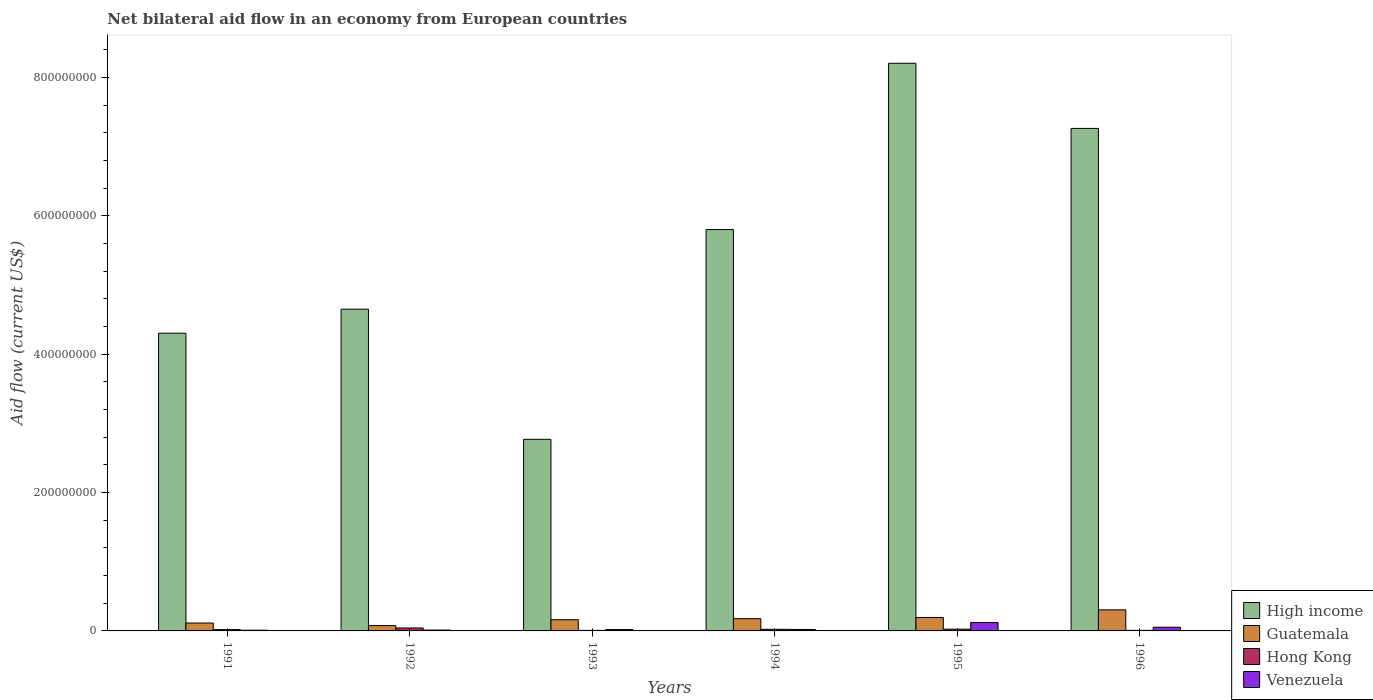How many different coloured bars are there?
Offer a terse response. 4. Are the number of bars per tick equal to the number of legend labels?
Offer a very short reply. Yes. How many bars are there on the 3rd tick from the left?
Provide a succinct answer. 4. How many bars are there on the 5th tick from the right?
Your answer should be compact. 4. What is the label of the 4th group of bars from the left?
Keep it short and to the point. 1994. What is the net bilateral aid flow in Guatemala in 1993?
Keep it short and to the point. 1.62e+07. Across all years, what is the maximum net bilateral aid flow in Hong Kong?
Offer a terse response. 4.26e+06. Across all years, what is the minimum net bilateral aid flow in High income?
Provide a succinct answer. 2.77e+08. What is the total net bilateral aid flow in Guatemala in the graph?
Provide a short and direct response. 1.03e+08. What is the difference between the net bilateral aid flow in Hong Kong in 1994 and that in 1996?
Your answer should be compact. 1.54e+06. What is the difference between the net bilateral aid flow in High income in 1993 and the net bilateral aid flow in Venezuela in 1996?
Make the answer very short. 2.72e+08. What is the average net bilateral aid flow in Hong Kong per year?
Your response must be concise. 2.11e+06. In the year 1992, what is the difference between the net bilateral aid flow in Guatemala and net bilateral aid flow in High income?
Ensure brevity in your answer.  -4.57e+08. In how many years, is the net bilateral aid flow in Venezuela greater than 720000000 US$?
Provide a succinct answer. 0. Is the difference between the net bilateral aid flow in Guatemala in 1991 and 1994 greater than the difference between the net bilateral aid flow in High income in 1991 and 1994?
Your response must be concise. Yes. What is the difference between the highest and the second highest net bilateral aid flow in High income?
Ensure brevity in your answer.  9.42e+07. What is the difference between the highest and the lowest net bilateral aid flow in Hong Kong?
Make the answer very short. 3.49e+06. Is it the case that in every year, the sum of the net bilateral aid flow in Guatemala and net bilateral aid flow in Venezuela is greater than the sum of net bilateral aid flow in High income and net bilateral aid flow in Hong Kong?
Provide a short and direct response. No. What does the 2nd bar from the left in 1994 represents?
Your response must be concise. Guatemala. What does the 3rd bar from the right in 1994 represents?
Ensure brevity in your answer.  Guatemala. Is it the case that in every year, the sum of the net bilateral aid flow in High income and net bilateral aid flow in Venezuela is greater than the net bilateral aid flow in Hong Kong?
Give a very brief answer. Yes. How many bars are there?
Your answer should be very brief. 24. How many years are there in the graph?
Provide a short and direct response. 6. Are the values on the major ticks of Y-axis written in scientific E-notation?
Your answer should be very brief. No. Does the graph contain grids?
Give a very brief answer. No. What is the title of the graph?
Offer a very short reply. Net bilateral aid flow in an economy from European countries. Does "Turkey" appear as one of the legend labels in the graph?
Provide a succinct answer. No. What is the label or title of the X-axis?
Your answer should be very brief. Years. What is the Aid flow (current US$) of High income in 1991?
Offer a very short reply. 4.30e+08. What is the Aid flow (current US$) in Guatemala in 1991?
Ensure brevity in your answer.  1.14e+07. What is the Aid flow (current US$) of Hong Kong in 1991?
Your answer should be compact. 1.92e+06. What is the Aid flow (current US$) of High income in 1992?
Keep it short and to the point. 4.65e+08. What is the Aid flow (current US$) of Guatemala in 1992?
Provide a short and direct response. 7.70e+06. What is the Aid flow (current US$) in Hong Kong in 1992?
Offer a terse response. 4.26e+06. What is the Aid flow (current US$) of Venezuela in 1992?
Provide a short and direct response. 1.30e+06. What is the Aid flow (current US$) of High income in 1993?
Your response must be concise. 2.77e+08. What is the Aid flow (current US$) of Guatemala in 1993?
Give a very brief answer. 1.62e+07. What is the Aid flow (current US$) of Hong Kong in 1993?
Give a very brief answer. 7.70e+05. What is the Aid flow (current US$) of Venezuela in 1993?
Your answer should be compact. 2.03e+06. What is the Aid flow (current US$) in High income in 1994?
Offer a terse response. 5.80e+08. What is the Aid flow (current US$) in Guatemala in 1994?
Provide a short and direct response. 1.77e+07. What is the Aid flow (current US$) of Hong Kong in 1994?
Keep it short and to the point. 2.34e+06. What is the Aid flow (current US$) of Venezuela in 1994?
Your answer should be compact. 2.14e+06. What is the Aid flow (current US$) of High income in 1995?
Give a very brief answer. 8.20e+08. What is the Aid flow (current US$) in Guatemala in 1995?
Your response must be concise. 1.94e+07. What is the Aid flow (current US$) of Hong Kong in 1995?
Keep it short and to the point. 2.57e+06. What is the Aid flow (current US$) in Venezuela in 1995?
Offer a terse response. 1.21e+07. What is the Aid flow (current US$) in High income in 1996?
Your answer should be very brief. 7.26e+08. What is the Aid flow (current US$) of Guatemala in 1996?
Offer a terse response. 3.04e+07. What is the Aid flow (current US$) in Hong Kong in 1996?
Your response must be concise. 8.00e+05. What is the Aid flow (current US$) of Venezuela in 1996?
Provide a short and direct response. 5.33e+06. Across all years, what is the maximum Aid flow (current US$) of High income?
Your answer should be very brief. 8.20e+08. Across all years, what is the maximum Aid flow (current US$) in Guatemala?
Provide a short and direct response. 3.04e+07. Across all years, what is the maximum Aid flow (current US$) in Hong Kong?
Keep it short and to the point. 4.26e+06. Across all years, what is the maximum Aid flow (current US$) in Venezuela?
Your answer should be compact. 1.21e+07. Across all years, what is the minimum Aid flow (current US$) in High income?
Your answer should be compact. 2.77e+08. Across all years, what is the minimum Aid flow (current US$) in Guatemala?
Your answer should be very brief. 7.70e+06. Across all years, what is the minimum Aid flow (current US$) of Hong Kong?
Keep it short and to the point. 7.70e+05. What is the total Aid flow (current US$) in High income in the graph?
Provide a succinct answer. 3.30e+09. What is the total Aid flow (current US$) in Guatemala in the graph?
Provide a short and direct response. 1.03e+08. What is the total Aid flow (current US$) of Hong Kong in the graph?
Make the answer very short. 1.27e+07. What is the total Aid flow (current US$) in Venezuela in the graph?
Ensure brevity in your answer.  2.39e+07. What is the difference between the Aid flow (current US$) in High income in 1991 and that in 1992?
Your response must be concise. -3.48e+07. What is the difference between the Aid flow (current US$) in Guatemala in 1991 and that in 1992?
Your answer should be very brief. 3.71e+06. What is the difference between the Aid flow (current US$) of Hong Kong in 1991 and that in 1992?
Make the answer very short. -2.34e+06. What is the difference between the Aid flow (current US$) of High income in 1991 and that in 1993?
Your answer should be very brief. 1.53e+08. What is the difference between the Aid flow (current US$) in Guatemala in 1991 and that in 1993?
Give a very brief answer. -4.78e+06. What is the difference between the Aid flow (current US$) of Hong Kong in 1991 and that in 1993?
Provide a short and direct response. 1.15e+06. What is the difference between the Aid flow (current US$) in Venezuela in 1991 and that in 1993?
Offer a very short reply. -1.03e+06. What is the difference between the Aid flow (current US$) in High income in 1991 and that in 1994?
Provide a succinct answer. -1.50e+08. What is the difference between the Aid flow (current US$) of Guatemala in 1991 and that in 1994?
Keep it short and to the point. -6.28e+06. What is the difference between the Aid flow (current US$) in Hong Kong in 1991 and that in 1994?
Give a very brief answer. -4.20e+05. What is the difference between the Aid flow (current US$) in Venezuela in 1991 and that in 1994?
Your answer should be very brief. -1.14e+06. What is the difference between the Aid flow (current US$) of High income in 1991 and that in 1995?
Provide a short and direct response. -3.90e+08. What is the difference between the Aid flow (current US$) in Guatemala in 1991 and that in 1995?
Keep it short and to the point. -8.02e+06. What is the difference between the Aid flow (current US$) of Hong Kong in 1991 and that in 1995?
Provide a succinct answer. -6.50e+05. What is the difference between the Aid flow (current US$) in Venezuela in 1991 and that in 1995?
Offer a very short reply. -1.11e+07. What is the difference between the Aid flow (current US$) of High income in 1991 and that in 1996?
Ensure brevity in your answer.  -2.96e+08. What is the difference between the Aid flow (current US$) in Guatemala in 1991 and that in 1996?
Provide a short and direct response. -1.90e+07. What is the difference between the Aid flow (current US$) in Hong Kong in 1991 and that in 1996?
Offer a very short reply. 1.12e+06. What is the difference between the Aid flow (current US$) of Venezuela in 1991 and that in 1996?
Keep it short and to the point. -4.33e+06. What is the difference between the Aid flow (current US$) in High income in 1992 and that in 1993?
Make the answer very short. 1.88e+08. What is the difference between the Aid flow (current US$) in Guatemala in 1992 and that in 1993?
Give a very brief answer. -8.49e+06. What is the difference between the Aid flow (current US$) of Hong Kong in 1992 and that in 1993?
Your answer should be very brief. 3.49e+06. What is the difference between the Aid flow (current US$) in Venezuela in 1992 and that in 1993?
Offer a terse response. -7.30e+05. What is the difference between the Aid flow (current US$) of High income in 1992 and that in 1994?
Provide a succinct answer. -1.15e+08. What is the difference between the Aid flow (current US$) in Guatemala in 1992 and that in 1994?
Offer a very short reply. -9.99e+06. What is the difference between the Aid flow (current US$) of Hong Kong in 1992 and that in 1994?
Offer a terse response. 1.92e+06. What is the difference between the Aid flow (current US$) of Venezuela in 1992 and that in 1994?
Provide a succinct answer. -8.40e+05. What is the difference between the Aid flow (current US$) of High income in 1992 and that in 1995?
Your answer should be compact. -3.55e+08. What is the difference between the Aid flow (current US$) in Guatemala in 1992 and that in 1995?
Your answer should be compact. -1.17e+07. What is the difference between the Aid flow (current US$) in Hong Kong in 1992 and that in 1995?
Your response must be concise. 1.69e+06. What is the difference between the Aid flow (current US$) in Venezuela in 1992 and that in 1995?
Your response must be concise. -1.08e+07. What is the difference between the Aid flow (current US$) in High income in 1992 and that in 1996?
Ensure brevity in your answer.  -2.61e+08. What is the difference between the Aid flow (current US$) in Guatemala in 1992 and that in 1996?
Give a very brief answer. -2.27e+07. What is the difference between the Aid flow (current US$) in Hong Kong in 1992 and that in 1996?
Offer a very short reply. 3.46e+06. What is the difference between the Aid flow (current US$) of Venezuela in 1992 and that in 1996?
Make the answer very short. -4.03e+06. What is the difference between the Aid flow (current US$) of High income in 1993 and that in 1994?
Give a very brief answer. -3.03e+08. What is the difference between the Aid flow (current US$) in Guatemala in 1993 and that in 1994?
Your answer should be compact. -1.50e+06. What is the difference between the Aid flow (current US$) of Hong Kong in 1993 and that in 1994?
Give a very brief answer. -1.57e+06. What is the difference between the Aid flow (current US$) in Venezuela in 1993 and that in 1994?
Provide a succinct answer. -1.10e+05. What is the difference between the Aid flow (current US$) in High income in 1993 and that in 1995?
Your answer should be very brief. -5.43e+08. What is the difference between the Aid flow (current US$) in Guatemala in 1993 and that in 1995?
Give a very brief answer. -3.24e+06. What is the difference between the Aid flow (current US$) in Hong Kong in 1993 and that in 1995?
Your response must be concise. -1.80e+06. What is the difference between the Aid flow (current US$) in Venezuela in 1993 and that in 1995?
Give a very brief answer. -1.01e+07. What is the difference between the Aid flow (current US$) of High income in 1993 and that in 1996?
Offer a terse response. -4.49e+08. What is the difference between the Aid flow (current US$) of Guatemala in 1993 and that in 1996?
Provide a succinct answer. -1.42e+07. What is the difference between the Aid flow (current US$) of Hong Kong in 1993 and that in 1996?
Your response must be concise. -3.00e+04. What is the difference between the Aid flow (current US$) in Venezuela in 1993 and that in 1996?
Keep it short and to the point. -3.30e+06. What is the difference between the Aid flow (current US$) of High income in 1994 and that in 1995?
Offer a terse response. -2.40e+08. What is the difference between the Aid flow (current US$) of Guatemala in 1994 and that in 1995?
Provide a succinct answer. -1.74e+06. What is the difference between the Aid flow (current US$) of Hong Kong in 1994 and that in 1995?
Keep it short and to the point. -2.30e+05. What is the difference between the Aid flow (current US$) of Venezuela in 1994 and that in 1995?
Give a very brief answer. -9.96e+06. What is the difference between the Aid flow (current US$) of High income in 1994 and that in 1996?
Your response must be concise. -1.46e+08. What is the difference between the Aid flow (current US$) of Guatemala in 1994 and that in 1996?
Your answer should be compact. -1.27e+07. What is the difference between the Aid flow (current US$) of Hong Kong in 1994 and that in 1996?
Provide a succinct answer. 1.54e+06. What is the difference between the Aid flow (current US$) of Venezuela in 1994 and that in 1996?
Your response must be concise. -3.19e+06. What is the difference between the Aid flow (current US$) in High income in 1995 and that in 1996?
Ensure brevity in your answer.  9.42e+07. What is the difference between the Aid flow (current US$) in Guatemala in 1995 and that in 1996?
Your answer should be compact. -1.10e+07. What is the difference between the Aid flow (current US$) of Hong Kong in 1995 and that in 1996?
Your response must be concise. 1.77e+06. What is the difference between the Aid flow (current US$) in Venezuela in 1995 and that in 1996?
Provide a succinct answer. 6.77e+06. What is the difference between the Aid flow (current US$) of High income in 1991 and the Aid flow (current US$) of Guatemala in 1992?
Provide a succinct answer. 4.23e+08. What is the difference between the Aid flow (current US$) in High income in 1991 and the Aid flow (current US$) in Hong Kong in 1992?
Give a very brief answer. 4.26e+08. What is the difference between the Aid flow (current US$) of High income in 1991 and the Aid flow (current US$) of Venezuela in 1992?
Your answer should be very brief. 4.29e+08. What is the difference between the Aid flow (current US$) in Guatemala in 1991 and the Aid flow (current US$) in Hong Kong in 1992?
Provide a short and direct response. 7.15e+06. What is the difference between the Aid flow (current US$) in Guatemala in 1991 and the Aid flow (current US$) in Venezuela in 1992?
Provide a succinct answer. 1.01e+07. What is the difference between the Aid flow (current US$) in Hong Kong in 1991 and the Aid flow (current US$) in Venezuela in 1992?
Provide a succinct answer. 6.20e+05. What is the difference between the Aid flow (current US$) in High income in 1991 and the Aid flow (current US$) in Guatemala in 1993?
Offer a terse response. 4.14e+08. What is the difference between the Aid flow (current US$) in High income in 1991 and the Aid flow (current US$) in Hong Kong in 1993?
Offer a terse response. 4.29e+08. What is the difference between the Aid flow (current US$) in High income in 1991 and the Aid flow (current US$) in Venezuela in 1993?
Provide a succinct answer. 4.28e+08. What is the difference between the Aid flow (current US$) in Guatemala in 1991 and the Aid flow (current US$) in Hong Kong in 1993?
Make the answer very short. 1.06e+07. What is the difference between the Aid flow (current US$) of Guatemala in 1991 and the Aid flow (current US$) of Venezuela in 1993?
Give a very brief answer. 9.38e+06. What is the difference between the Aid flow (current US$) of High income in 1991 and the Aid flow (current US$) of Guatemala in 1994?
Offer a terse response. 4.13e+08. What is the difference between the Aid flow (current US$) of High income in 1991 and the Aid flow (current US$) of Hong Kong in 1994?
Give a very brief answer. 4.28e+08. What is the difference between the Aid flow (current US$) in High income in 1991 and the Aid flow (current US$) in Venezuela in 1994?
Offer a terse response. 4.28e+08. What is the difference between the Aid flow (current US$) of Guatemala in 1991 and the Aid flow (current US$) of Hong Kong in 1994?
Provide a short and direct response. 9.07e+06. What is the difference between the Aid flow (current US$) of Guatemala in 1991 and the Aid flow (current US$) of Venezuela in 1994?
Your response must be concise. 9.27e+06. What is the difference between the Aid flow (current US$) of High income in 1991 and the Aid flow (current US$) of Guatemala in 1995?
Offer a very short reply. 4.11e+08. What is the difference between the Aid flow (current US$) in High income in 1991 and the Aid flow (current US$) in Hong Kong in 1995?
Provide a short and direct response. 4.28e+08. What is the difference between the Aid flow (current US$) in High income in 1991 and the Aid flow (current US$) in Venezuela in 1995?
Give a very brief answer. 4.18e+08. What is the difference between the Aid flow (current US$) of Guatemala in 1991 and the Aid flow (current US$) of Hong Kong in 1995?
Give a very brief answer. 8.84e+06. What is the difference between the Aid flow (current US$) of Guatemala in 1991 and the Aid flow (current US$) of Venezuela in 1995?
Offer a terse response. -6.90e+05. What is the difference between the Aid flow (current US$) in Hong Kong in 1991 and the Aid flow (current US$) in Venezuela in 1995?
Provide a short and direct response. -1.02e+07. What is the difference between the Aid flow (current US$) of High income in 1991 and the Aid flow (current US$) of Guatemala in 1996?
Your response must be concise. 4.00e+08. What is the difference between the Aid flow (current US$) in High income in 1991 and the Aid flow (current US$) in Hong Kong in 1996?
Ensure brevity in your answer.  4.29e+08. What is the difference between the Aid flow (current US$) in High income in 1991 and the Aid flow (current US$) in Venezuela in 1996?
Provide a short and direct response. 4.25e+08. What is the difference between the Aid flow (current US$) in Guatemala in 1991 and the Aid flow (current US$) in Hong Kong in 1996?
Give a very brief answer. 1.06e+07. What is the difference between the Aid flow (current US$) in Guatemala in 1991 and the Aid flow (current US$) in Venezuela in 1996?
Your response must be concise. 6.08e+06. What is the difference between the Aid flow (current US$) of Hong Kong in 1991 and the Aid flow (current US$) of Venezuela in 1996?
Your answer should be very brief. -3.41e+06. What is the difference between the Aid flow (current US$) in High income in 1992 and the Aid flow (current US$) in Guatemala in 1993?
Your response must be concise. 4.49e+08. What is the difference between the Aid flow (current US$) in High income in 1992 and the Aid flow (current US$) in Hong Kong in 1993?
Provide a short and direct response. 4.64e+08. What is the difference between the Aid flow (current US$) of High income in 1992 and the Aid flow (current US$) of Venezuela in 1993?
Give a very brief answer. 4.63e+08. What is the difference between the Aid flow (current US$) in Guatemala in 1992 and the Aid flow (current US$) in Hong Kong in 1993?
Your answer should be very brief. 6.93e+06. What is the difference between the Aid flow (current US$) of Guatemala in 1992 and the Aid flow (current US$) of Venezuela in 1993?
Keep it short and to the point. 5.67e+06. What is the difference between the Aid flow (current US$) of Hong Kong in 1992 and the Aid flow (current US$) of Venezuela in 1993?
Your response must be concise. 2.23e+06. What is the difference between the Aid flow (current US$) of High income in 1992 and the Aid flow (current US$) of Guatemala in 1994?
Provide a succinct answer. 4.47e+08. What is the difference between the Aid flow (current US$) of High income in 1992 and the Aid flow (current US$) of Hong Kong in 1994?
Provide a short and direct response. 4.63e+08. What is the difference between the Aid flow (current US$) in High income in 1992 and the Aid flow (current US$) in Venezuela in 1994?
Ensure brevity in your answer.  4.63e+08. What is the difference between the Aid flow (current US$) of Guatemala in 1992 and the Aid flow (current US$) of Hong Kong in 1994?
Your answer should be compact. 5.36e+06. What is the difference between the Aid flow (current US$) in Guatemala in 1992 and the Aid flow (current US$) in Venezuela in 1994?
Offer a terse response. 5.56e+06. What is the difference between the Aid flow (current US$) in Hong Kong in 1992 and the Aid flow (current US$) in Venezuela in 1994?
Your response must be concise. 2.12e+06. What is the difference between the Aid flow (current US$) in High income in 1992 and the Aid flow (current US$) in Guatemala in 1995?
Ensure brevity in your answer.  4.46e+08. What is the difference between the Aid flow (current US$) in High income in 1992 and the Aid flow (current US$) in Hong Kong in 1995?
Offer a very short reply. 4.62e+08. What is the difference between the Aid flow (current US$) in High income in 1992 and the Aid flow (current US$) in Venezuela in 1995?
Give a very brief answer. 4.53e+08. What is the difference between the Aid flow (current US$) of Guatemala in 1992 and the Aid flow (current US$) of Hong Kong in 1995?
Your response must be concise. 5.13e+06. What is the difference between the Aid flow (current US$) of Guatemala in 1992 and the Aid flow (current US$) of Venezuela in 1995?
Make the answer very short. -4.40e+06. What is the difference between the Aid flow (current US$) in Hong Kong in 1992 and the Aid flow (current US$) in Venezuela in 1995?
Provide a succinct answer. -7.84e+06. What is the difference between the Aid flow (current US$) in High income in 1992 and the Aid flow (current US$) in Guatemala in 1996?
Offer a very short reply. 4.35e+08. What is the difference between the Aid flow (current US$) in High income in 1992 and the Aid flow (current US$) in Hong Kong in 1996?
Offer a very short reply. 4.64e+08. What is the difference between the Aid flow (current US$) of High income in 1992 and the Aid flow (current US$) of Venezuela in 1996?
Offer a very short reply. 4.60e+08. What is the difference between the Aid flow (current US$) of Guatemala in 1992 and the Aid flow (current US$) of Hong Kong in 1996?
Your response must be concise. 6.90e+06. What is the difference between the Aid flow (current US$) of Guatemala in 1992 and the Aid flow (current US$) of Venezuela in 1996?
Your response must be concise. 2.37e+06. What is the difference between the Aid flow (current US$) in Hong Kong in 1992 and the Aid flow (current US$) in Venezuela in 1996?
Give a very brief answer. -1.07e+06. What is the difference between the Aid flow (current US$) of High income in 1993 and the Aid flow (current US$) of Guatemala in 1994?
Provide a succinct answer. 2.59e+08. What is the difference between the Aid flow (current US$) in High income in 1993 and the Aid flow (current US$) in Hong Kong in 1994?
Offer a terse response. 2.75e+08. What is the difference between the Aid flow (current US$) of High income in 1993 and the Aid flow (current US$) of Venezuela in 1994?
Offer a very short reply. 2.75e+08. What is the difference between the Aid flow (current US$) of Guatemala in 1993 and the Aid flow (current US$) of Hong Kong in 1994?
Keep it short and to the point. 1.38e+07. What is the difference between the Aid flow (current US$) in Guatemala in 1993 and the Aid flow (current US$) in Venezuela in 1994?
Your answer should be very brief. 1.40e+07. What is the difference between the Aid flow (current US$) in Hong Kong in 1993 and the Aid flow (current US$) in Venezuela in 1994?
Offer a very short reply. -1.37e+06. What is the difference between the Aid flow (current US$) in High income in 1993 and the Aid flow (current US$) in Guatemala in 1995?
Give a very brief answer. 2.57e+08. What is the difference between the Aid flow (current US$) in High income in 1993 and the Aid flow (current US$) in Hong Kong in 1995?
Give a very brief answer. 2.74e+08. What is the difference between the Aid flow (current US$) of High income in 1993 and the Aid flow (current US$) of Venezuela in 1995?
Give a very brief answer. 2.65e+08. What is the difference between the Aid flow (current US$) of Guatemala in 1993 and the Aid flow (current US$) of Hong Kong in 1995?
Your response must be concise. 1.36e+07. What is the difference between the Aid flow (current US$) of Guatemala in 1993 and the Aid flow (current US$) of Venezuela in 1995?
Give a very brief answer. 4.09e+06. What is the difference between the Aid flow (current US$) of Hong Kong in 1993 and the Aid flow (current US$) of Venezuela in 1995?
Your answer should be very brief. -1.13e+07. What is the difference between the Aid flow (current US$) of High income in 1993 and the Aid flow (current US$) of Guatemala in 1996?
Provide a short and direct response. 2.46e+08. What is the difference between the Aid flow (current US$) in High income in 1993 and the Aid flow (current US$) in Hong Kong in 1996?
Your answer should be compact. 2.76e+08. What is the difference between the Aid flow (current US$) of High income in 1993 and the Aid flow (current US$) of Venezuela in 1996?
Provide a succinct answer. 2.72e+08. What is the difference between the Aid flow (current US$) in Guatemala in 1993 and the Aid flow (current US$) in Hong Kong in 1996?
Offer a very short reply. 1.54e+07. What is the difference between the Aid flow (current US$) of Guatemala in 1993 and the Aid flow (current US$) of Venezuela in 1996?
Provide a short and direct response. 1.09e+07. What is the difference between the Aid flow (current US$) of Hong Kong in 1993 and the Aid flow (current US$) of Venezuela in 1996?
Give a very brief answer. -4.56e+06. What is the difference between the Aid flow (current US$) in High income in 1994 and the Aid flow (current US$) in Guatemala in 1995?
Give a very brief answer. 5.61e+08. What is the difference between the Aid flow (current US$) in High income in 1994 and the Aid flow (current US$) in Hong Kong in 1995?
Your answer should be compact. 5.77e+08. What is the difference between the Aid flow (current US$) in High income in 1994 and the Aid flow (current US$) in Venezuela in 1995?
Keep it short and to the point. 5.68e+08. What is the difference between the Aid flow (current US$) in Guatemala in 1994 and the Aid flow (current US$) in Hong Kong in 1995?
Offer a terse response. 1.51e+07. What is the difference between the Aid flow (current US$) of Guatemala in 1994 and the Aid flow (current US$) of Venezuela in 1995?
Provide a succinct answer. 5.59e+06. What is the difference between the Aid flow (current US$) in Hong Kong in 1994 and the Aid flow (current US$) in Venezuela in 1995?
Provide a short and direct response. -9.76e+06. What is the difference between the Aid flow (current US$) of High income in 1994 and the Aid flow (current US$) of Guatemala in 1996?
Offer a terse response. 5.50e+08. What is the difference between the Aid flow (current US$) in High income in 1994 and the Aid flow (current US$) in Hong Kong in 1996?
Provide a succinct answer. 5.79e+08. What is the difference between the Aid flow (current US$) of High income in 1994 and the Aid flow (current US$) of Venezuela in 1996?
Your response must be concise. 5.75e+08. What is the difference between the Aid flow (current US$) in Guatemala in 1994 and the Aid flow (current US$) in Hong Kong in 1996?
Offer a very short reply. 1.69e+07. What is the difference between the Aid flow (current US$) of Guatemala in 1994 and the Aid flow (current US$) of Venezuela in 1996?
Provide a short and direct response. 1.24e+07. What is the difference between the Aid flow (current US$) in Hong Kong in 1994 and the Aid flow (current US$) in Venezuela in 1996?
Ensure brevity in your answer.  -2.99e+06. What is the difference between the Aid flow (current US$) in High income in 1995 and the Aid flow (current US$) in Guatemala in 1996?
Ensure brevity in your answer.  7.90e+08. What is the difference between the Aid flow (current US$) in High income in 1995 and the Aid flow (current US$) in Hong Kong in 1996?
Offer a terse response. 8.20e+08. What is the difference between the Aid flow (current US$) of High income in 1995 and the Aid flow (current US$) of Venezuela in 1996?
Your answer should be compact. 8.15e+08. What is the difference between the Aid flow (current US$) of Guatemala in 1995 and the Aid flow (current US$) of Hong Kong in 1996?
Your answer should be compact. 1.86e+07. What is the difference between the Aid flow (current US$) in Guatemala in 1995 and the Aid flow (current US$) in Venezuela in 1996?
Your answer should be very brief. 1.41e+07. What is the difference between the Aid flow (current US$) of Hong Kong in 1995 and the Aid flow (current US$) of Venezuela in 1996?
Your answer should be very brief. -2.76e+06. What is the average Aid flow (current US$) of High income per year?
Provide a short and direct response. 5.50e+08. What is the average Aid flow (current US$) in Guatemala per year?
Give a very brief answer. 1.71e+07. What is the average Aid flow (current US$) in Hong Kong per year?
Ensure brevity in your answer.  2.11e+06. What is the average Aid flow (current US$) in Venezuela per year?
Offer a very short reply. 3.98e+06. In the year 1991, what is the difference between the Aid flow (current US$) of High income and Aid flow (current US$) of Guatemala?
Your response must be concise. 4.19e+08. In the year 1991, what is the difference between the Aid flow (current US$) of High income and Aid flow (current US$) of Hong Kong?
Your answer should be very brief. 4.28e+08. In the year 1991, what is the difference between the Aid flow (current US$) of High income and Aid flow (current US$) of Venezuela?
Provide a succinct answer. 4.29e+08. In the year 1991, what is the difference between the Aid flow (current US$) of Guatemala and Aid flow (current US$) of Hong Kong?
Offer a very short reply. 9.49e+06. In the year 1991, what is the difference between the Aid flow (current US$) of Guatemala and Aid flow (current US$) of Venezuela?
Make the answer very short. 1.04e+07. In the year 1991, what is the difference between the Aid flow (current US$) of Hong Kong and Aid flow (current US$) of Venezuela?
Provide a succinct answer. 9.20e+05. In the year 1992, what is the difference between the Aid flow (current US$) in High income and Aid flow (current US$) in Guatemala?
Your answer should be very brief. 4.57e+08. In the year 1992, what is the difference between the Aid flow (current US$) in High income and Aid flow (current US$) in Hong Kong?
Your answer should be compact. 4.61e+08. In the year 1992, what is the difference between the Aid flow (current US$) in High income and Aid flow (current US$) in Venezuela?
Provide a succinct answer. 4.64e+08. In the year 1992, what is the difference between the Aid flow (current US$) in Guatemala and Aid flow (current US$) in Hong Kong?
Your response must be concise. 3.44e+06. In the year 1992, what is the difference between the Aid flow (current US$) of Guatemala and Aid flow (current US$) of Venezuela?
Your answer should be compact. 6.40e+06. In the year 1992, what is the difference between the Aid flow (current US$) of Hong Kong and Aid flow (current US$) of Venezuela?
Make the answer very short. 2.96e+06. In the year 1993, what is the difference between the Aid flow (current US$) in High income and Aid flow (current US$) in Guatemala?
Make the answer very short. 2.61e+08. In the year 1993, what is the difference between the Aid flow (current US$) of High income and Aid flow (current US$) of Hong Kong?
Make the answer very short. 2.76e+08. In the year 1993, what is the difference between the Aid flow (current US$) in High income and Aid flow (current US$) in Venezuela?
Offer a very short reply. 2.75e+08. In the year 1993, what is the difference between the Aid flow (current US$) of Guatemala and Aid flow (current US$) of Hong Kong?
Make the answer very short. 1.54e+07. In the year 1993, what is the difference between the Aid flow (current US$) in Guatemala and Aid flow (current US$) in Venezuela?
Offer a terse response. 1.42e+07. In the year 1993, what is the difference between the Aid flow (current US$) in Hong Kong and Aid flow (current US$) in Venezuela?
Your answer should be compact. -1.26e+06. In the year 1994, what is the difference between the Aid flow (current US$) of High income and Aid flow (current US$) of Guatemala?
Ensure brevity in your answer.  5.62e+08. In the year 1994, what is the difference between the Aid flow (current US$) in High income and Aid flow (current US$) in Hong Kong?
Make the answer very short. 5.78e+08. In the year 1994, what is the difference between the Aid flow (current US$) of High income and Aid flow (current US$) of Venezuela?
Offer a very short reply. 5.78e+08. In the year 1994, what is the difference between the Aid flow (current US$) in Guatemala and Aid flow (current US$) in Hong Kong?
Ensure brevity in your answer.  1.54e+07. In the year 1994, what is the difference between the Aid flow (current US$) in Guatemala and Aid flow (current US$) in Venezuela?
Provide a succinct answer. 1.56e+07. In the year 1994, what is the difference between the Aid flow (current US$) of Hong Kong and Aid flow (current US$) of Venezuela?
Your answer should be very brief. 2.00e+05. In the year 1995, what is the difference between the Aid flow (current US$) of High income and Aid flow (current US$) of Guatemala?
Provide a short and direct response. 8.01e+08. In the year 1995, what is the difference between the Aid flow (current US$) of High income and Aid flow (current US$) of Hong Kong?
Your answer should be compact. 8.18e+08. In the year 1995, what is the difference between the Aid flow (current US$) in High income and Aid flow (current US$) in Venezuela?
Make the answer very short. 8.08e+08. In the year 1995, what is the difference between the Aid flow (current US$) of Guatemala and Aid flow (current US$) of Hong Kong?
Provide a short and direct response. 1.69e+07. In the year 1995, what is the difference between the Aid flow (current US$) of Guatemala and Aid flow (current US$) of Venezuela?
Provide a short and direct response. 7.33e+06. In the year 1995, what is the difference between the Aid flow (current US$) of Hong Kong and Aid flow (current US$) of Venezuela?
Ensure brevity in your answer.  -9.53e+06. In the year 1996, what is the difference between the Aid flow (current US$) in High income and Aid flow (current US$) in Guatemala?
Ensure brevity in your answer.  6.96e+08. In the year 1996, what is the difference between the Aid flow (current US$) of High income and Aid flow (current US$) of Hong Kong?
Keep it short and to the point. 7.25e+08. In the year 1996, what is the difference between the Aid flow (current US$) of High income and Aid flow (current US$) of Venezuela?
Give a very brief answer. 7.21e+08. In the year 1996, what is the difference between the Aid flow (current US$) in Guatemala and Aid flow (current US$) in Hong Kong?
Keep it short and to the point. 2.96e+07. In the year 1996, what is the difference between the Aid flow (current US$) in Guatemala and Aid flow (current US$) in Venezuela?
Make the answer very short. 2.51e+07. In the year 1996, what is the difference between the Aid flow (current US$) in Hong Kong and Aid flow (current US$) in Venezuela?
Your answer should be compact. -4.53e+06. What is the ratio of the Aid flow (current US$) in High income in 1991 to that in 1992?
Ensure brevity in your answer.  0.93. What is the ratio of the Aid flow (current US$) in Guatemala in 1991 to that in 1992?
Your response must be concise. 1.48. What is the ratio of the Aid flow (current US$) in Hong Kong in 1991 to that in 1992?
Your answer should be very brief. 0.45. What is the ratio of the Aid flow (current US$) of Venezuela in 1991 to that in 1992?
Provide a short and direct response. 0.77. What is the ratio of the Aid flow (current US$) in High income in 1991 to that in 1993?
Offer a terse response. 1.55. What is the ratio of the Aid flow (current US$) in Guatemala in 1991 to that in 1993?
Keep it short and to the point. 0.7. What is the ratio of the Aid flow (current US$) of Hong Kong in 1991 to that in 1993?
Give a very brief answer. 2.49. What is the ratio of the Aid flow (current US$) in Venezuela in 1991 to that in 1993?
Offer a terse response. 0.49. What is the ratio of the Aid flow (current US$) in High income in 1991 to that in 1994?
Provide a succinct answer. 0.74. What is the ratio of the Aid flow (current US$) of Guatemala in 1991 to that in 1994?
Ensure brevity in your answer.  0.65. What is the ratio of the Aid flow (current US$) of Hong Kong in 1991 to that in 1994?
Your answer should be compact. 0.82. What is the ratio of the Aid flow (current US$) in Venezuela in 1991 to that in 1994?
Ensure brevity in your answer.  0.47. What is the ratio of the Aid flow (current US$) of High income in 1991 to that in 1995?
Offer a very short reply. 0.52. What is the ratio of the Aid flow (current US$) of Guatemala in 1991 to that in 1995?
Keep it short and to the point. 0.59. What is the ratio of the Aid flow (current US$) of Hong Kong in 1991 to that in 1995?
Give a very brief answer. 0.75. What is the ratio of the Aid flow (current US$) in Venezuela in 1991 to that in 1995?
Ensure brevity in your answer.  0.08. What is the ratio of the Aid flow (current US$) in High income in 1991 to that in 1996?
Offer a very short reply. 0.59. What is the ratio of the Aid flow (current US$) of Guatemala in 1991 to that in 1996?
Provide a succinct answer. 0.38. What is the ratio of the Aid flow (current US$) in Venezuela in 1991 to that in 1996?
Make the answer very short. 0.19. What is the ratio of the Aid flow (current US$) in High income in 1992 to that in 1993?
Your answer should be compact. 1.68. What is the ratio of the Aid flow (current US$) of Guatemala in 1992 to that in 1993?
Provide a succinct answer. 0.48. What is the ratio of the Aid flow (current US$) of Hong Kong in 1992 to that in 1993?
Your answer should be compact. 5.53. What is the ratio of the Aid flow (current US$) in Venezuela in 1992 to that in 1993?
Your answer should be very brief. 0.64. What is the ratio of the Aid flow (current US$) in High income in 1992 to that in 1994?
Provide a succinct answer. 0.8. What is the ratio of the Aid flow (current US$) of Guatemala in 1992 to that in 1994?
Provide a succinct answer. 0.44. What is the ratio of the Aid flow (current US$) in Hong Kong in 1992 to that in 1994?
Offer a terse response. 1.82. What is the ratio of the Aid flow (current US$) in Venezuela in 1992 to that in 1994?
Ensure brevity in your answer.  0.61. What is the ratio of the Aid flow (current US$) of High income in 1992 to that in 1995?
Keep it short and to the point. 0.57. What is the ratio of the Aid flow (current US$) in Guatemala in 1992 to that in 1995?
Provide a short and direct response. 0.4. What is the ratio of the Aid flow (current US$) of Hong Kong in 1992 to that in 1995?
Make the answer very short. 1.66. What is the ratio of the Aid flow (current US$) in Venezuela in 1992 to that in 1995?
Ensure brevity in your answer.  0.11. What is the ratio of the Aid flow (current US$) in High income in 1992 to that in 1996?
Give a very brief answer. 0.64. What is the ratio of the Aid flow (current US$) in Guatemala in 1992 to that in 1996?
Your answer should be compact. 0.25. What is the ratio of the Aid flow (current US$) of Hong Kong in 1992 to that in 1996?
Your answer should be very brief. 5.33. What is the ratio of the Aid flow (current US$) in Venezuela in 1992 to that in 1996?
Keep it short and to the point. 0.24. What is the ratio of the Aid flow (current US$) in High income in 1993 to that in 1994?
Offer a terse response. 0.48. What is the ratio of the Aid flow (current US$) of Guatemala in 1993 to that in 1994?
Provide a succinct answer. 0.92. What is the ratio of the Aid flow (current US$) of Hong Kong in 1993 to that in 1994?
Keep it short and to the point. 0.33. What is the ratio of the Aid flow (current US$) in Venezuela in 1993 to that in 1994?
Your answer should be compact. 0.95. What is the ratio of the Aid flow (current US$) in High income in 1993 to that in 1995?
Provide a succinct answer. 0.34. What is the ratio of the Aid flow (current US$) of Guatemala in 1993 to that in 1995?
Make the answer very short. 0.83. What is the ratio of the Aid flow (current US$) of Hong Kong in 1993 to that in 1995?
Provide a short and direct response. 0.3. What is the ratio of the Aid flow (current US$) in Venezuela in 1993 to that in 1995?
Ensure brevity in your answer.  0.17. What is the ratio of the Aid flow (current US$) of High income in 1993 to that in 1996?
Provide a succinct answer. 0.38. What is the ratio of the Aid flow (current US$) of Guatemala in 1993 to that in 1996?
Give a very brief answer. 0.53. What is the ratio of the Aid flow (current US$) in Hong Kong in 1993 to that in 1996?
Give a very brief answer. 0.96. What is the ratio of the Aid flow (current US$) in Venezuela in 1993 to that in 1996?
Your response must be concise. 0.38. What is the ratio of the Aid flow (current US$) of High income in 1994 to that in 1995?
Your response must be concise. 0.71. What is the ratio of the Aid flow (current US$) in Guatemala in 1994 to that in 1995?
Make the answer very short. 0.91. What is the ratio of the Aid flow (current US$) in Hong Kong in 1994 to that in 1995?
Give a very brief answer. 0.91. What is the ratio of the Aid flow (current US$) in Venezuela in 1994 to that in 1995?
Offer a very short reply. 0.18. What is the ratio of the Aid flow (current US$) of High income in 1994 to that in 1996?
Provide a short and direct response. 0.8. What is the ratio of the Aid flow (current US$) in Guatemala in 1994 to that in 1996?
Your answer should be very brief. 0.58. What is the ratio of the Aid flow (current US$) of Hong Kong in 1994 to that in 1996?
Your answer should be very brief. 2.92. What is the ratio of the Aid flow (current US$) in Venezuela in 1994 to that in 1996?
Provide a short and direct response. 0.4. What is the ratio of the Aid flow (current US$) in High income in 1995 to that in 1996?
Provide a succinct answer. 1.13. What is the ratio of the Aid flow (current US$) in Guatemala in 1995 to that in 1996?
Your response must be concise. 0.64. What is the ratio of the Aid flow (current US$) in Hong Kong in 1995 to that in 1996?
Provide a succinct answer. 3.21. What is the ratio of the Aid flow (current US$) of Venezuela in 1995 to that in 1996?
Give a very brief answer. 2.27. What is the difference between the highest and the second highest Aid flow (current US$) in High income?
Make the answer very short. 9.42e+07. What is the difference between the highest and the second highest Aid flow (current US$) of Guatemala?
Your response must be concise. 1.10e+07. What is the difference between the highest and the second highest Aid flow (current US$) of Hong Kong?
Keep it short and to the point. 1.69e+06. What is the difference between the highest and the second highest Aid flow (current US$) in Venezuela?
Provide a succinct answer. 6.77e+06. What is the difference between the highest and the lowest Aid flow (current US$) in High income?
Make the answer very short. 5.43e+08. What is the difference between the highest and the lowest Aid flow (current US$) of Guatemala?
Your response must be concise. 2.27e+07. What is the difference between the highest and the lowest Aid flow (current US$) in Hong Kong?
Your answer should be very brief. 3.49e+06. What is the difference between the highest and the lowest Aid flow (current US$) of Venezuela?
Make the answer very short. 1.11e+07. 